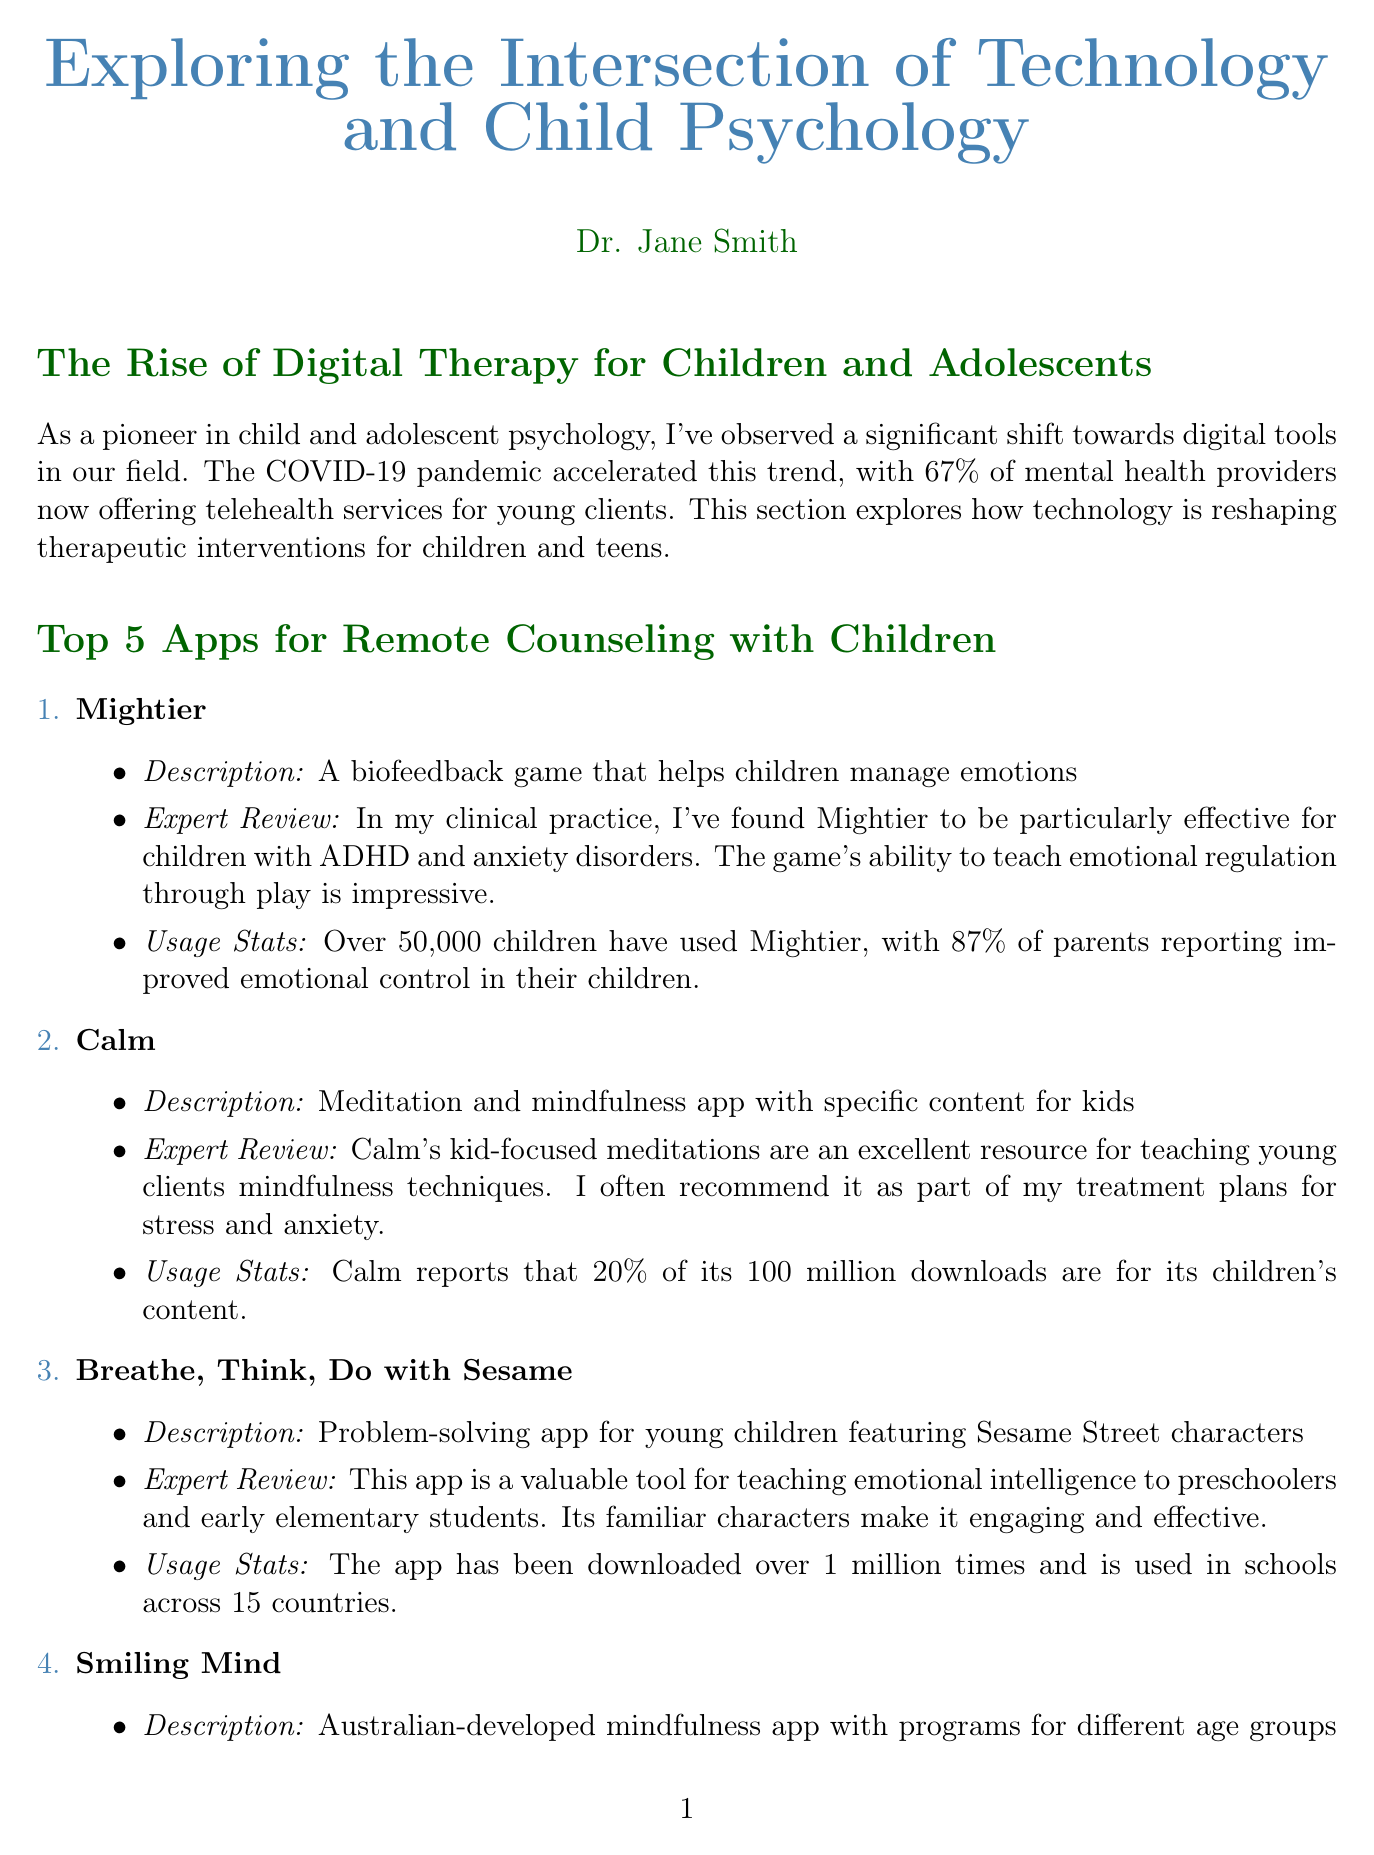What percentage of mental health providers offer telehealth services for young clients? The document states that 67% of mental health providers now offer telehealth services for young clients.
Answer: 67% How many children have used the app Mightier? The document indicates that over 50,000 children have used Mightier.
Answer: Over 50,000 Which app is particularly effective for children with ADHD and anxiety disorders? Mightier is noted in the document for its effectiveness with children who have ADHD and anxiety disorders.
Answer: Mightier How many downloads does the app Calm have for its children's content? Calm reports that 20% of its 100 million downloads are specifically for children's content.
Answer: 20% What feature does Doxy.me offer for child psychologists? The document mentions that Doxy.me provides HIPAA-compliant video conferencing with a child-friendly interface.
Answer: HIPAA-compliant video conferencing What is the primary focus of the current research mentioned in the newsletter? The newsletter highlights that the current research focuses on developing VR environments for treating childhood phobias.
Answer: VR environments for treating childhood phobias How many mental health professionals does TheraNest serve? The document states that TheraNest is serving over 40,000 mental health professionals.
Answer: Over 40,000 Which app has been downloaded over 1 million times and is used in schools across how many countries? Breathe, Think, Do with Sesame has been downloaded over 1 million times and is used in schools across 15 countries.
Answer: 15 countries 